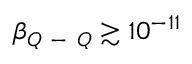<formula> <loc_0><loc_0><loc_500><loc_500>\beta _ { Q - Q } \gtrsim 1 0 ^ { - 1 1 }</formula> 